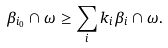<formula> <loc_0><loc_0><loc_500><loc_500>\beta _ { i _ { 0 } } \cap \omega \geq \sum _ { i } k _ { i } \beta _ { i } \cap \omega .</formula> 